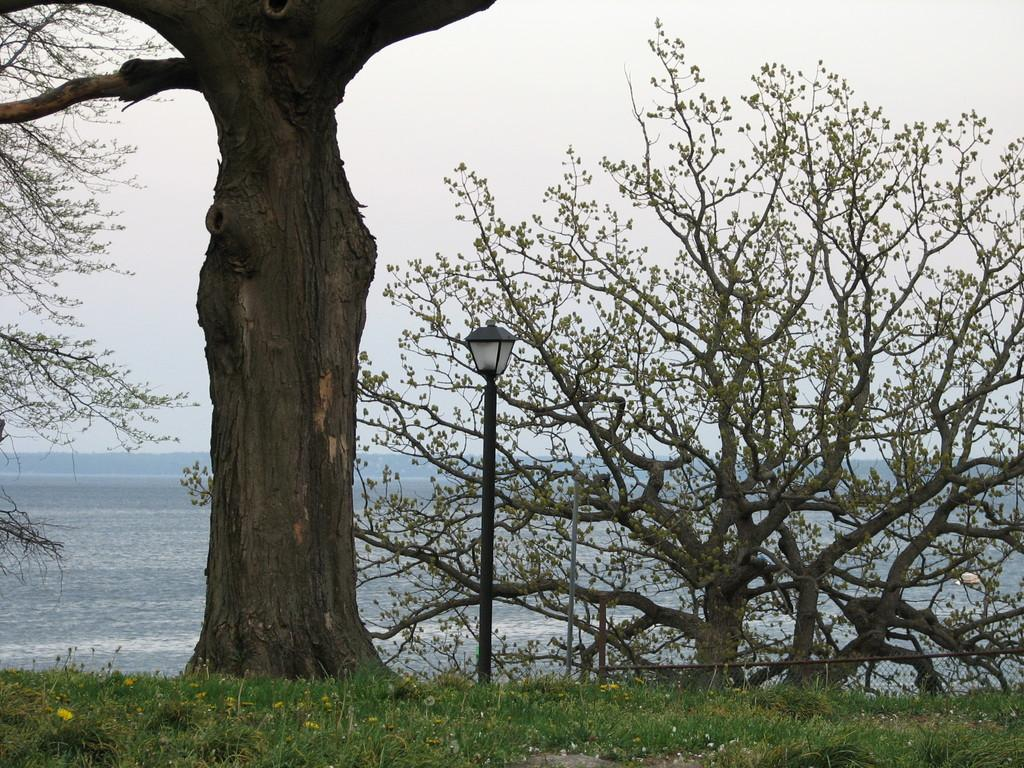What type of vegetation can be seen in the image? There are trees and flowers in the image. What is on the ground in the image? There is grass on the ground in the image. What type of artificial light source is present in the image? There is a pole light in the image. What can be seen in the background of the image? There is water visible in the background of the image. What is visible above the ground in the image? The sky is visible in the image. What type of patch is visible on the skin of the person in the image? There is no person present in the image, so there is no skin or patch visible. What type of shop can be seen in the image? There is no shop present in the image. 